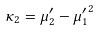<formula> <loc_0><loc_0><loc_500><loc_500>\kappa _ { 2 } = \mu _ { 2 } ^ { \prime } - { \mu _ { 1 } ^ { \prime } } ^ { 2 }</formula> 